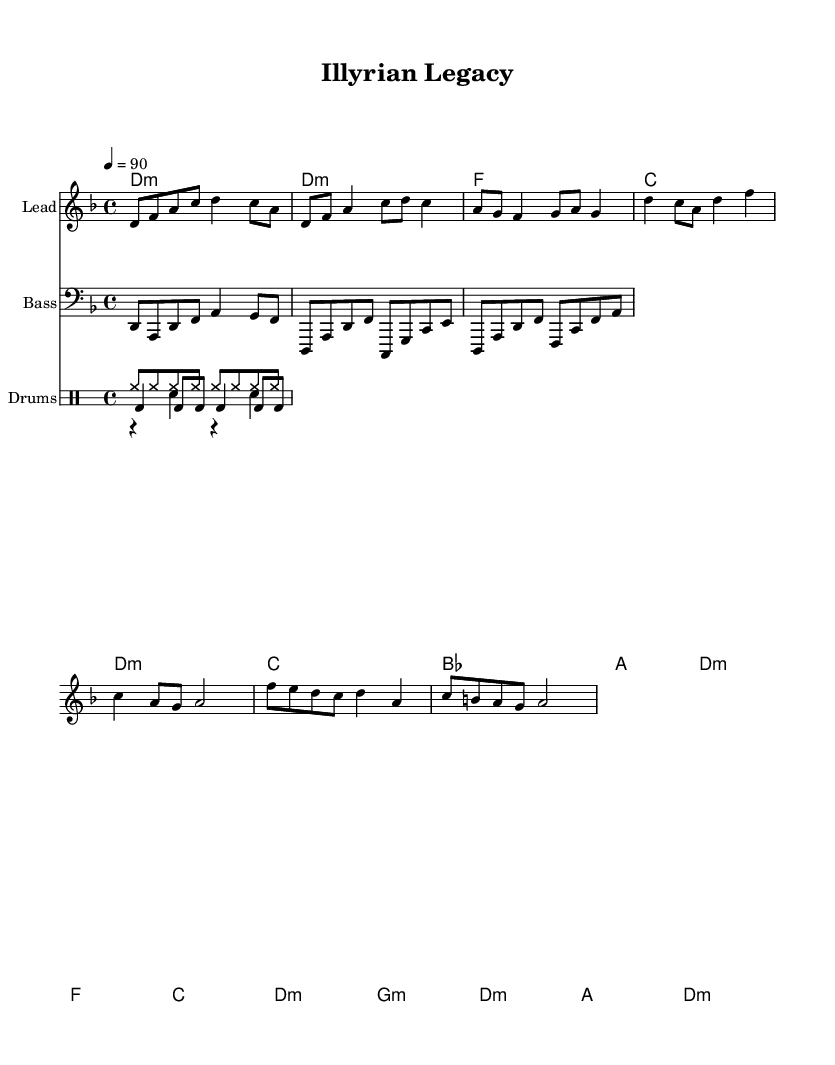What is the key signature of this music? The key signature is D minor, indicated by one flat (B flat).
Answer: D minor What is the time signature of the piece? The time signature is 4/4, shown at the beginning of the score.
Answer: 4/4 What is the tempo marking for this piece? The tempo marking is 4 = 90, meaning 90 beats per minute.
Answer: 90 How many measures are in the chorus section? The chorus has two measures, which can be visually counted in the section labeled as "Chorus".
Answer: 2 What instruments are featured in the score? The score features three instruments: Lead, Bass, and Drums, as indicated at the beginning of each staff.
Answer: Lead, Bass, Drums What are the first two chords played in the intro? The first two chords are D minor and D minor, as shown in the chord symbols above the melody.
Answer: D minor, D minor In which section is the bridge located? The bridge is indicated as "Bridge" in the score, and it follows the chorus section, clearly labeled for ease of identification.
Answer: Bridge 